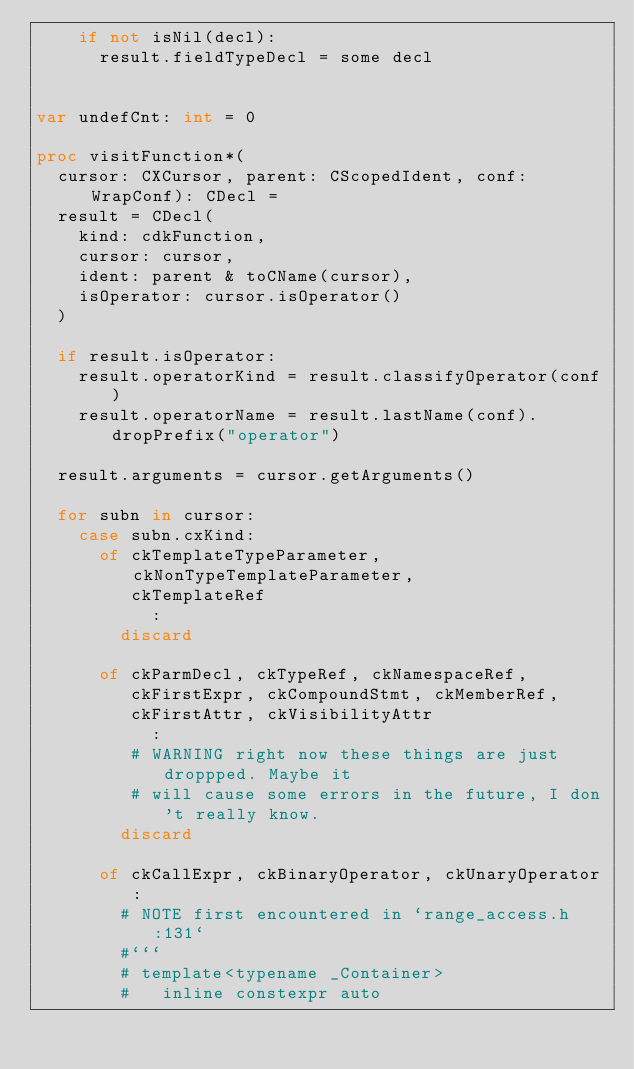<code> <loc_0><loc_0><loc_500><loc_500><_Nim_>    if not isNil(decl):
      result.fieldTypeDecl = some decl


var undefCnt: int = 0

proc visitFunction*(
  cursor: CXCursor, parent: CScopedIdent, conf: WrapConf): CDecl =
  result = CDecl(
    kind: cdkFunction,
    cursor: cursor,
    ident: parent & toCName(cursor),
    isOperator: cursor.isOperator()
  )

  if result.isOperator:
    result.operatorKind = result.classifyOperator(conf)
    result.operatorName = result.lastName(conf).dropPrefix("operator")

  result.arguments = cursor.getArguments()

  for subn in cursor:
    case subn.cxKind:
      of ckTemplateTypeParameter, ckNonTypeTemplateParameter,
         ckTemplateRef
           :
        discard

      of ckParmDecl, ckTypeRef, ckNamespaceRef,
         ckFirstExpr, ckCompoundStmt, ckMemberRef,
         ckFirstAttr, ckVisibilityAttr
           :
         # WARNING right now these things are just droppped. Maybe it
         # will cause some errors in the future, I don't really know.
        discard

      of ckCallExpr, ckBinaryOperator, ckUnaryOperator:
        # NOTE first encountered in `range_access.h:131`
        #```
        # template<typename _Container>
        #   inline constexpr auto</code> 